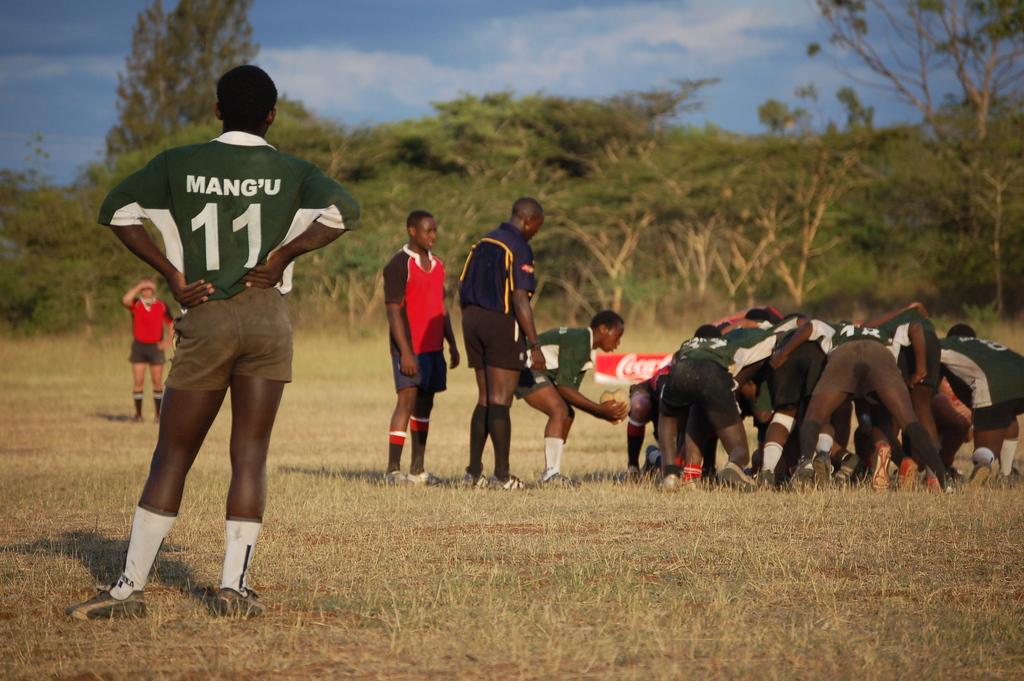What number is the left player?
Your answer should be compact. 11. 